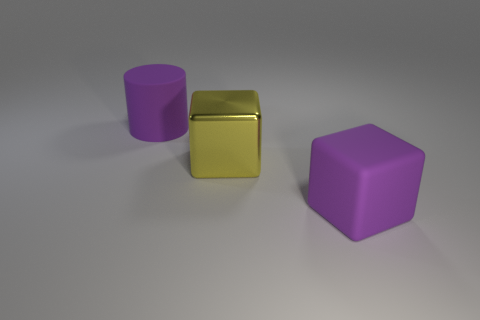Add 3 yellow things. How many objects exist? 6 Subtract all cylinders. How many objects are left? 2 Subtract all big purple rubber cylinders. Subtract all cyan matte balls. How many objects are left? 2 Add 2 large matte blocks. How many large matte blocks are left? 3 Add 2 blocks. How many blocks exist? 4 Subtract 0 blue blocks. How many objects are left? 3 